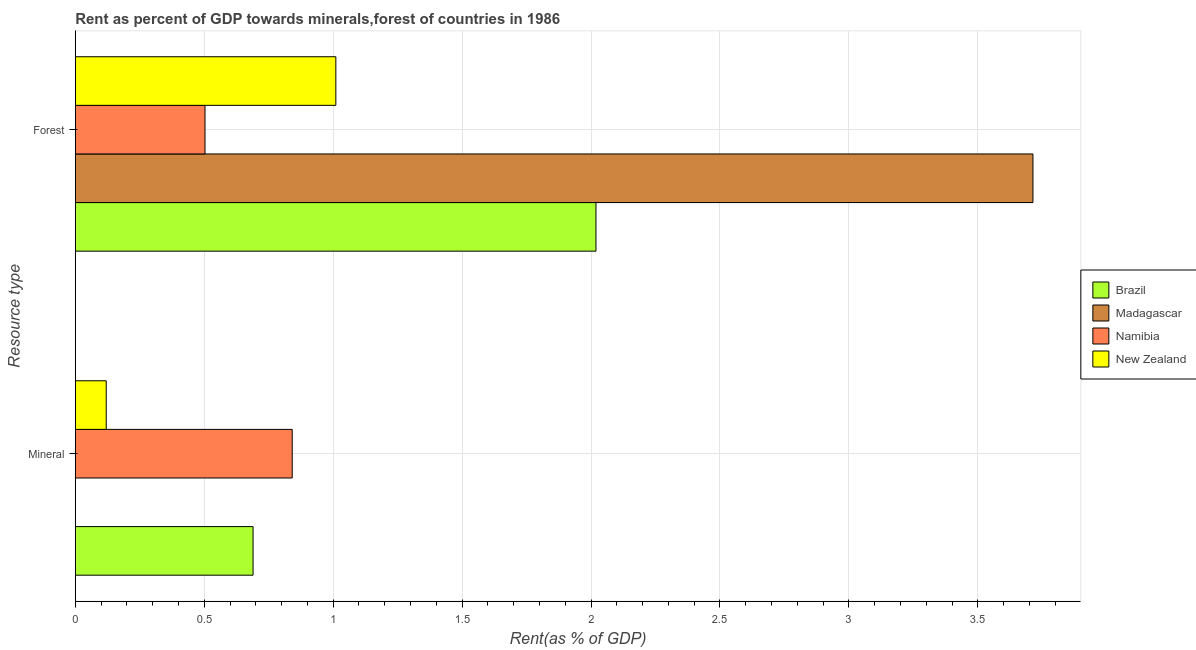How many groups of bars are there?
Keep it short and to the point. 2. Are the number of bars per tick equal to the number of legend labels?
Offer a terse response. Yes. How many bars are there on the 1st tick from the bottom?
Your response must be concise. 4. What is the label of the 1st group of bars from the top?
Offer a terse response. Forest. What is the mineral rent in Madagascar?
Ensure brevity in your answer.  0. Across all countries, what is the maximum forest rent?
Your response must be concise. 3.71. Across all countries, what is the minimum forest rent?
Your answer should be compact. 0.5. In which country was the mineral rent maximum?
Offer a very short reply. Namibia. In which country was the mineral rent minimum?
Offer a terse response. Madagascar. What is the total forest rent in the graph?
Offer a terse response. 7.25. What is the difference between the forest rent in Namibia and that in New Zealand?
Provide a short and direct response. -0.51. What is the difference between the mineral rent in Namibia and the forest rent in New Zealand?
Give a very brief answer. -0.17. What is the average mineral rent per country?
Give a very brief answer. 0.41. What is the difference between the mineral rent and forest rent in Brazil?
Ensure brevity in your answer.  -1.33. In how many countries, is the mineral rent greater than 3.4 %?
Offer a very short reply. 0. What is the ratio of the mineral rent in New Zealand to that in Madagascar?
Keep it short and to the point. 286.24. What does the 3rd bar from the top in Mineral represents?
Provide a short and direct response. Madagascar. What does the 4th bar from the bottom in Mineral represents?
Your response must be concise. New Zealand. How many countries are there in the graph?
Your answer should be compact. 4. What is the difference between two consecutive major ticks on the X-axis?
Provide a succinct answer. 0.5. How many legend labels are there?
Make the answer very short. 4. What is the title of the graph?
Keep it short and to the point. Rent as percent of GDP towards minerals,forest of countries in 1986. What is the label or title of the X-axis?
Offer a very short reply. Rent(as % of GDP). What is the label or title of the Y-axis?
Offer a terse response. Resource type. What is the Rent(as % of GDP) of Brazil in Mineral?
Offer a terse response. 0.69. What is the Rent(as % of GDP) in Madagascar in Mineral?
Offer a very short reply. 0. What is the Rent(as % of GDP) in Namibia in Mineral?
Give a very brief answer. 0.84. What is the Rent(as % of GDP) in New Zealand in Mineral?
Your response must be concise. 0.12. What is the Rent(as % of GDP) in Brazil in Forest?
Ensure brevity in your answer.  2.02. What is the Rent(as % of GDP) in Madagascar in Forest?
Offer a terse response. 3.71. What is the Rent(as % of GDP) of Namibia in Forest?
Give a very brief answer. 0.5. What is the Rent(as % of GDP) of New Zealand in Forest?
Your response must be concise. 1.01. Across all Resource type, what is the maximum Rent(as % of GDP) of Brazil?
Your answer should be very brief. 2.02. Across all Resource type, what is the maximum Rent(as % of GDP) in Madagascar?
Offer a very short reply. 3.71. Across all Resource type, what is the maximum Rent(as % of GDP) in Namibia?
Your response must be concise. 0.84. Across all Resource type, what is the maximum Rent(as % of GDP) in New Zealand?
Keep it short and to the point. 1.01. Across all Resource type, what is the minimum Rent(as % of GDP) of Brazil?
Offer a very short reply. 0.69. Across all Resource type, what is the minimum Rent(as % of GDP) in Madagascar?
Make the answer very short. 0. Across all Resource type, what is the minimum Rent(as % of GDP) in Namibia?
Offer a terse response. 0.5. Across all Resource type, what is the minimum Rent(as % of GDP) in New Zealand?
Your response must be concise. 0.12. What is the total Rent(as % of GDP) in Brazil in the graph?
Keep it short and to the point. 2.71. What is the total Rent(as % of GDP) of Madagascar in the graph?
Provide a succinct answer. 3.71. What is the total Rent(as % of GDP) of Namibia in the graph?
Provide a succinct answer. 1.34. What is the total Rent(as % of GDP) in New Zealand in the graph?
Offer a terse response. 1.13. What is the difference between the Rent(as % of GDP) of Brazil in Mineral and that in Forest?
Provide a short and direct response. -1.33. What is the difference between the Rent(as % of GDP) of Madagascar in Mineral and that in Forest?
Offer a very short reply. -3.71. What is the difference between the Rent(as % of GDP) of Namibia in Mineral and that in Forest?
Offer a very short reply. 0.34. What is the difference between the Rent(as % of GDP) in New Zealand in Mineral and that in Forest?
Give a very brief answer. -0.89. What is the difference between the Rent(as % of GDP) of Brazil in Mineral and the Rent(as % of GDP) of Madagascar in Forest?
Make the answer very short. -3.02. What is the difference between the Rent(as % of GDP) of Brazil in Mineral and the Rent(as % of GDP) of Namibia in Forest?
Keep it short and to the point. 0.19. What is the difference between the Rent(as % of GDP) of Brazil in Mineral and the Rent(as % of GDP) of New Zealand in Forest?
Ensure brevity in your answer.  -0.32. What is the difference between the Rent(as % of GDP) in Madagascar in Mineral and the Rent(as % of GDP) in Namibia in Forest?
Provide a short and direct response. -0.5. What is the difference between the Rent(as % of GDP) of Madagascar in Mineral and the Rent(as % of GDP) of New Zealand in Forest?
Give a very brief answer. -1.01. What is the difference between the Rent(as % of GDP) of Namibia in Mineral and the Rent(as % of GDP) of New Zealand in Forest?
Make the answer very short. -0.17. What is the average Rent(as % of GDP) of Brazil per Resource type?
Ensure brevity in your answer.  1.35. What is the average Rent(as % of GDP) in Madagascar per Resource type?
Provide a short and direct response. 1.86. What is the average Rent(as % of GDP) of Namibia per Resource type?
Your answer should be compact. 0.67. What is the average Rent(as % of GDP) in New Zealand per Resource type?
Keep it short and to the point. 0.57. What is the difference between the Rent(as % of GDP) in Brazil and Rent(as % of GDP) in Madagascar in Mineral?
Offer a terse response. 0.69. What is the difference between the Rent(as % of GDP) in Brazil and Rent(as % of GDP) in Namibia in Mineral?
Offer a terse response. -0.15. What is the difference between the Rent(as % of GDP) of Brazil and Rent(as % of GDP) of New Zealand in Mineral?
Your answer should be compact. 0.57. What is the difference between the Rent(as % of GDP) of Madagascar and Rent(as % of GDP) of Namibia in Mineral?
Provide a short and direct response. -0.84. What is the difference between the Rent(as % of GDP) of Madagascar and Rent(as % of GDP) of New Zealand in Mineral?
Keep it short and to the point. -0.12. What is the difference between the Rent(as % of GDP) in Namibia and Rent(as % of GDP) in New Zealand in Mineral?
Your answer should be very brief. 0.72. What is the difference between the Rent(as % of GDP) in Brazil and Rent(as % of GDP) in Madagascar in Forest?
Offer a terse response. -1.69. What is the difference between the Rent(as % of GDP) of Brazil and Rent(as % of GDP) of Namibia in Forest?
Your answer should be compact. 1.52. What is the difference between the Rent(as % of GDP) in Brazil and Rent(as % of GDP) in New Zealand in Forest?
Keep it short and to the point. 1.01. What is the difference between the Rent(as % of GDP) of Madagascar and Rent(as % of GDP) of Namibia in Forest?
Your answer should be very brief. 3.21. What is the difference between the Rent(as % of GDP) in Madagascar and Rent(as % of GDP) in New Zealand in Forest?
Keep it short and to the point. 2.7. What is the difference between the Rent(as % of GDP) in Namibia and Rent(as % of GDP) in New Zealand in Forest?
Make the answer very short. -0.51. What is the ratio of the Rent(as % of GDP) in Brazil in Mineral to that in Forest?
Offer a terse response. 0.34. What is the ratio of the Rent(as % of GDP) in Namibia in Mineral to that in Forest?
Provide a succinct answer. 1.67. What is the ratio of the Rent(as % of GDP) in New Zealand in Mineral to that in Forest?
Your answer should be compact. 0.12. What is the difference between the highest and the second highest Rent(as % of GDP) of Brazil?
Give a very brief answer. 1.33. What is the difference between the highest and the second highest Rent(as % of GDP) in Madagascar?
Make the answer very short. 3.71. What is the difference between the highest and the second highest Rent(as % of GDP) of Namibia?
Your answer should be compact. 0.34. What is the difference between the highest and the second highest Rent(as % of GDP) of New Zealand?
Your answer should be compact. 0.89. What is the difference between the highest and the lowest Rent(as % of GDP) in Brazil?
Provide a succinct answer. 1.33. What is the difference between the highest and the lowest Rent(as % of GDP) in Madagascar?
Provide a succinct answer. 3.71. What is the difference between the highest and the lowest Rent(as % of GDP) of Namibia?
Provide a succinct answer. 0.34. What is the difference between the highest and the lowest Rent(as % of GDP) in New Zealand?
Your response must be concise. 0.89. 